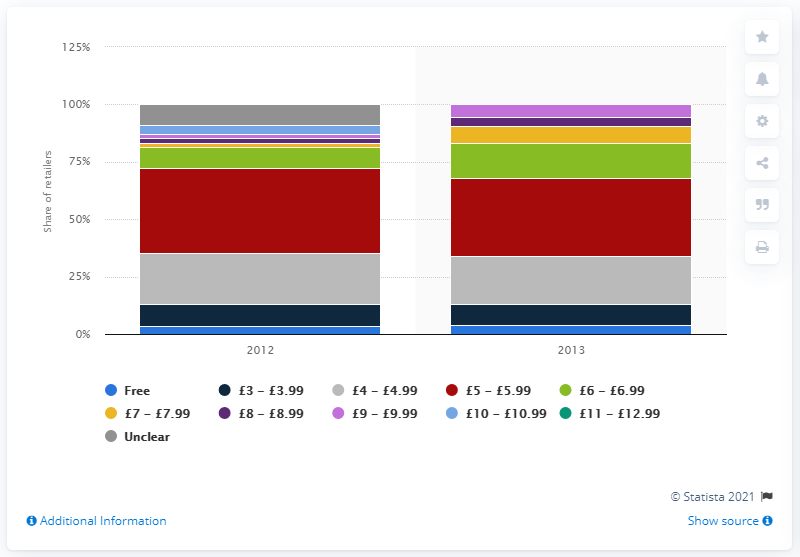Point out several critical features in this image. In 2013, approximately 3.8% of online retailers offered free next-day delivery services. 